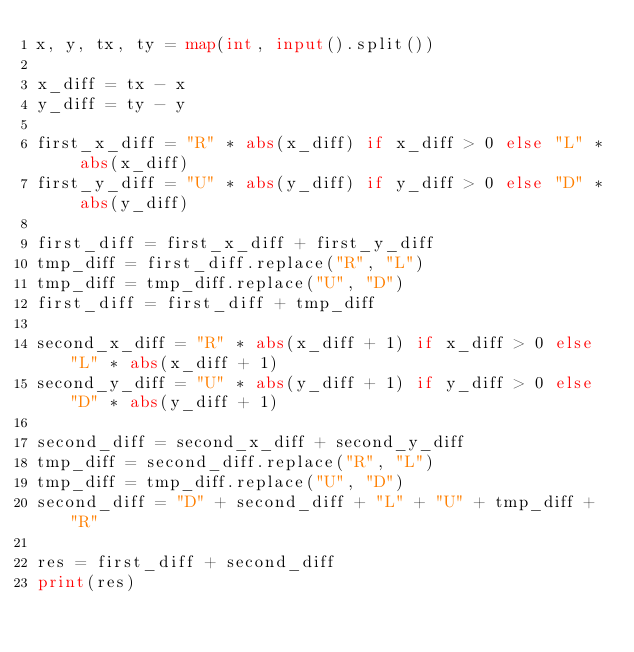Convert code to text. <code><loc_0><loc_0><loc_500><loc_500><_Python_>x, y, tx, ty = map(int, input().split())

x_diff = tx - x
y_diff = ty - y

first_x_diff = "R" * abs(x_diff) if x_diff > 0 else "L" * abs(x_diff)
first_y_diff = "U" * abs(y_diff) if y_diff > 0 else "D" * abs(y_diff)

first_diff = first_x_diff + first_y_diff
tmp_diff = first_diff.replace("R", "L")
tmp_diff = tmp_diff.replace("U", "D")
first_diff = first_diff + tmp_diff

second_x_diff = "R" * abs(x_diff + 1) if x_diff > 0 else "L" * abs(x_diff + 1)
second_y_diff = "U" * abs(y_diff + 1) if y_diff > 0 else "D" * abs(y_diff + 1)

second_diff = second_x_diff + second_y_diff
tmp_diff = second_diff.replace("R", "L")
tmp_diff = tmp_diff.replace("U", "D")
second_diff = "D" + second_diff + "L" + "U" + tmp_diff + "R"

res = first_diff + second_diff
print(res)
</code> 